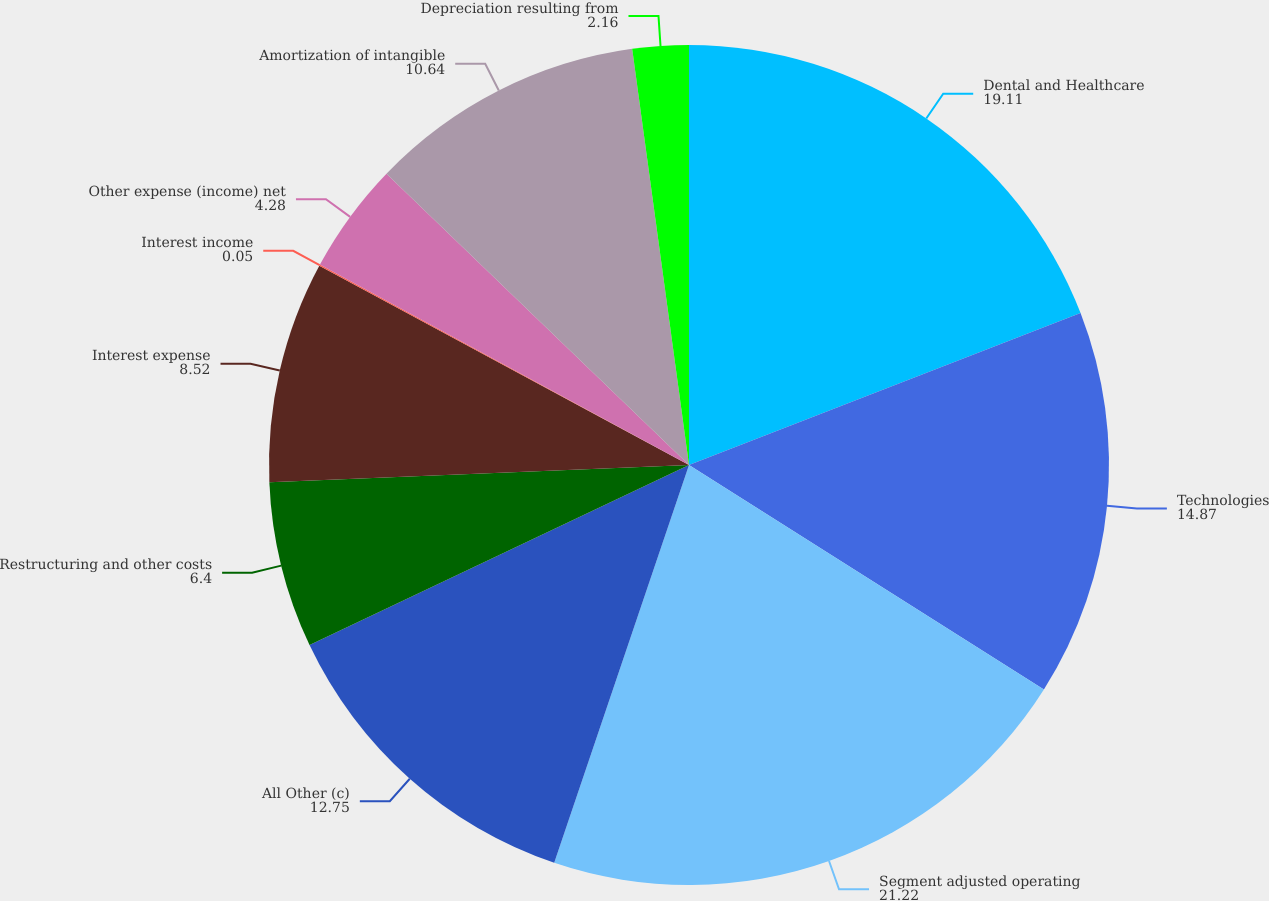Convert chart to OTSL. <chart><loc_0><loc_0><loc_500><loc_500><pie_chart><fcel>Dental and Healthcare<fcel>Technologies<fcel>Segment adjusted operating<fcel>All Other (c)<fcel>Restructuring and other costs<fcel>Interest expense<fcel>Interest income<fcel>Other expense (income) net<fcel>Amortization of intangible<fcel>Depreciation resulting from<nl><fcel>19.11%<fcel>14.87%<fcel>21.22%<fcel>12.75%<fcel>6.4%<fcel>8.52%<fcel>0.05%<fcel>4.28%<fcel>10.64%<fcel>2.16%<nl></chart> 